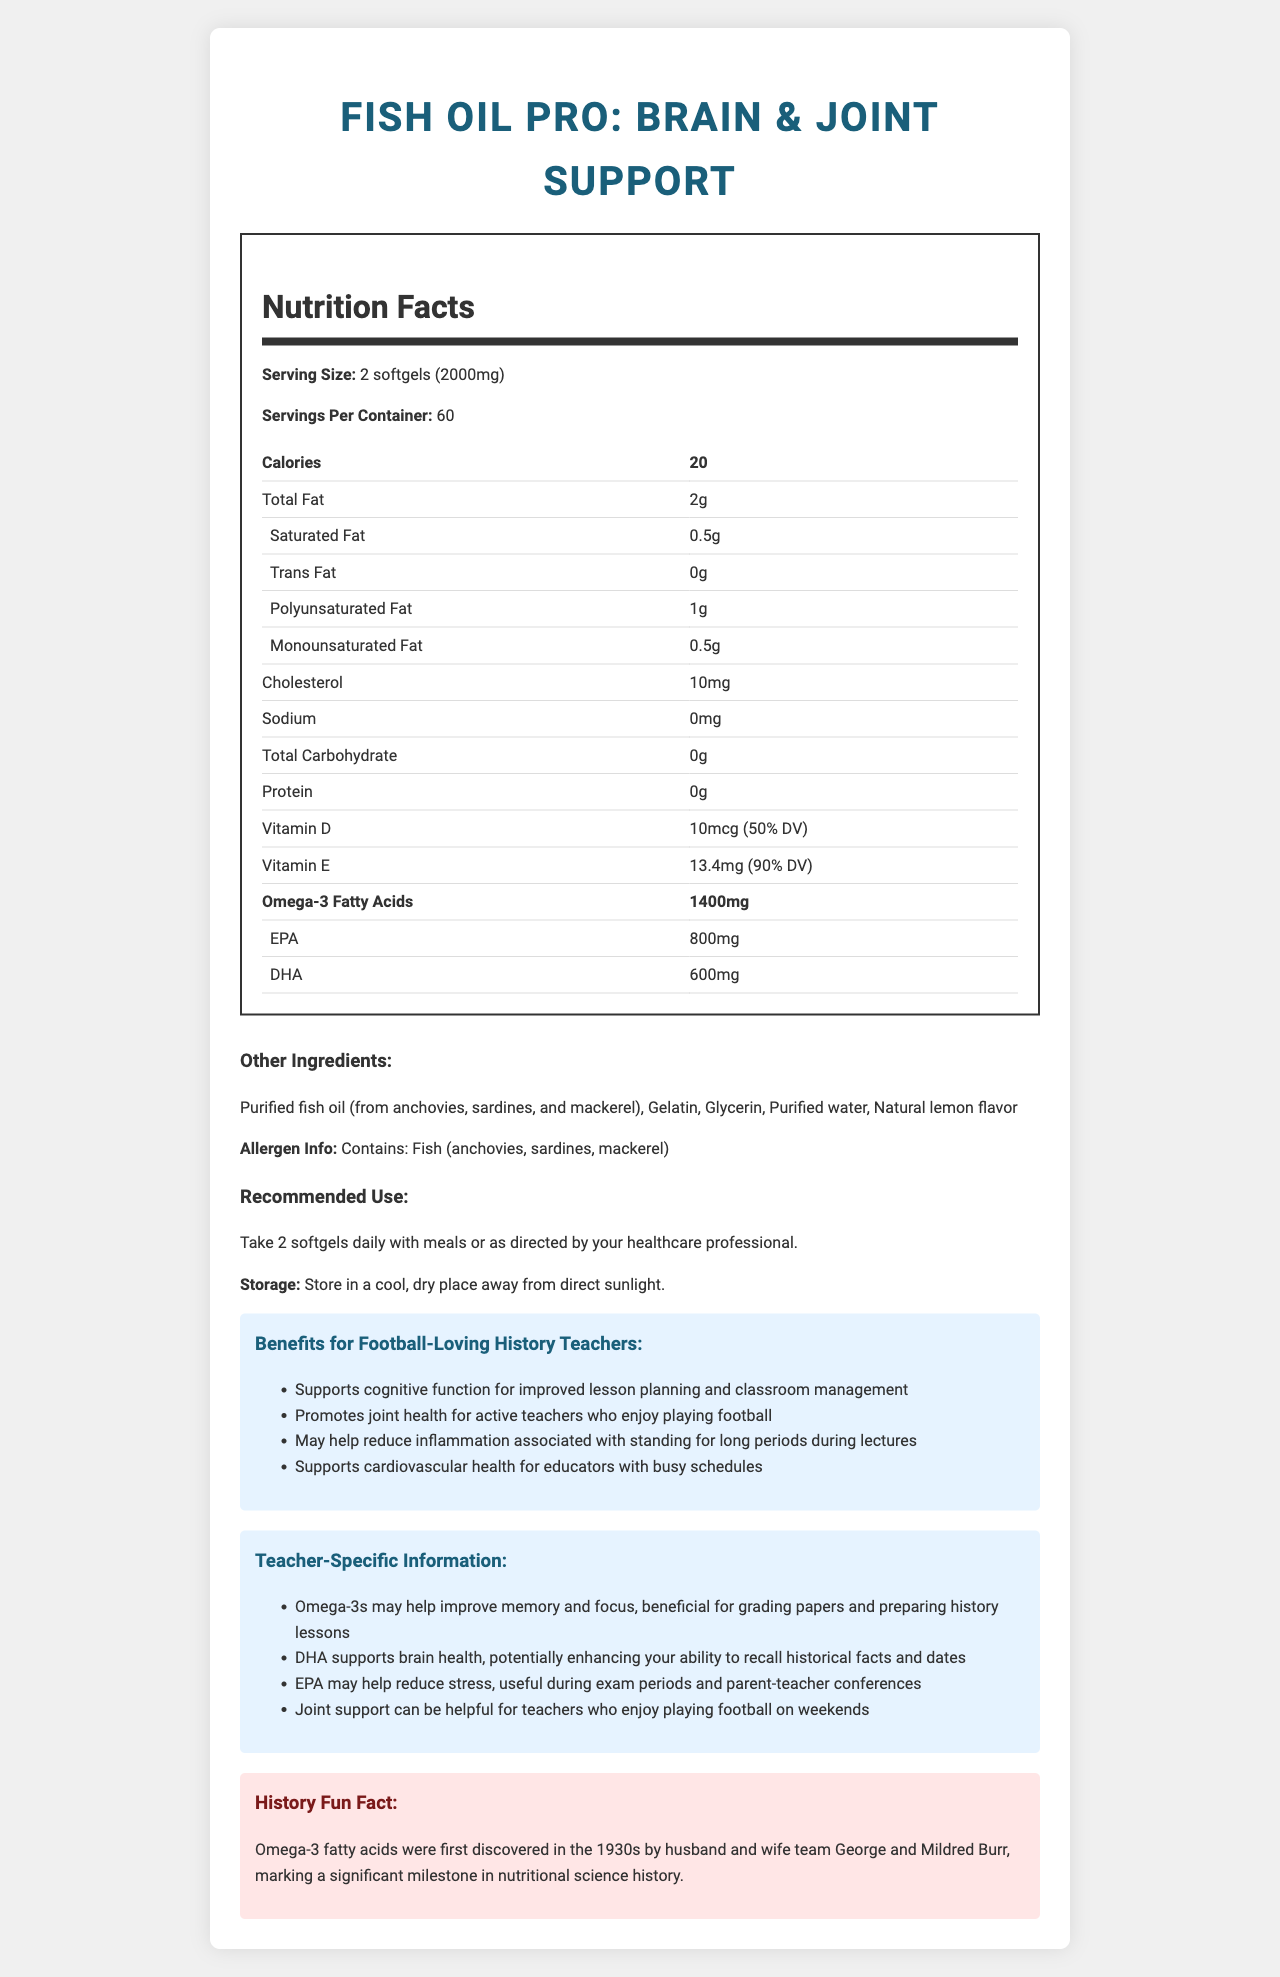what is the serving size of Fish Oil Pro: Brain & Joint Support? The serving size is clearly stated as "2 softgels (2000mg)" in the nutrition facts section.
Answer: 2 softgels (2000mg) How many calories are in a serving? The calories per serving are listed as 20.
Answer: 20 How much total fat does a serving contain? The document specifies that there are 2 grams of total fat per serving.
Answer: 2g What is the amount of Omega-3 fatty acids per serving? The nutrition facts label shows that there are 1400mg of Omega-3 fatty acids per serving.
Answer: 1400mg What types of fish are used in the fish oil supplement? The other ingredients section states that the purified fish oil is from anchovies, sardines, and mackerel.
Answer: Anchovies, sardines, mackerel Which vitamin has a daily value (DV) of 50% per serving? A. Vitamin E B. Vitamin D C. Vitamin C D. Vitamin A According to the nutrition facts, Vitamin D has a daily value of 50%.
Answer: B What are the benefits of Fish Oil Pro specifically for history teachers? A. Reduces joint pain B. Improves memory and focus C. Supports cardiovascular health D. Enhances brain health The teacher-specific information highlights that Omega-3s may improve memory and focus as well as DHA supporting brain health.
Answer: B, D Does the Fish Oil Pro contain any carbohydrates? The total carbohydrate content is listed as 0g, indicating no carbohydrates.
Answer: No Can the Fish Oil Pro help reduce inflammation? One of the listed benefits is that it may help reduce inflammation associated with standing for long periods.
Answer: Yes What is the main idea of the document? The document details the product name, serving size, nutritional content, recommended use, storage, benefits, teacher-specific information, and a history fun fact. It highlights the product's ingredients and potential health advantages.
Answer: The document provides the nutrition facts, benefits, and usage information for Fish Oil Pro: Brain & Joint Support, emphasizing its advantages for cognitive function, joint health, and specific benefits for high school history teachers. Where was George Burr born? The document mentions that George and Mildred Burr discovered Omega-3 fatty acids in the 1930s but does not provide information about George Burr's birthplace.
Answer: Not enough information 